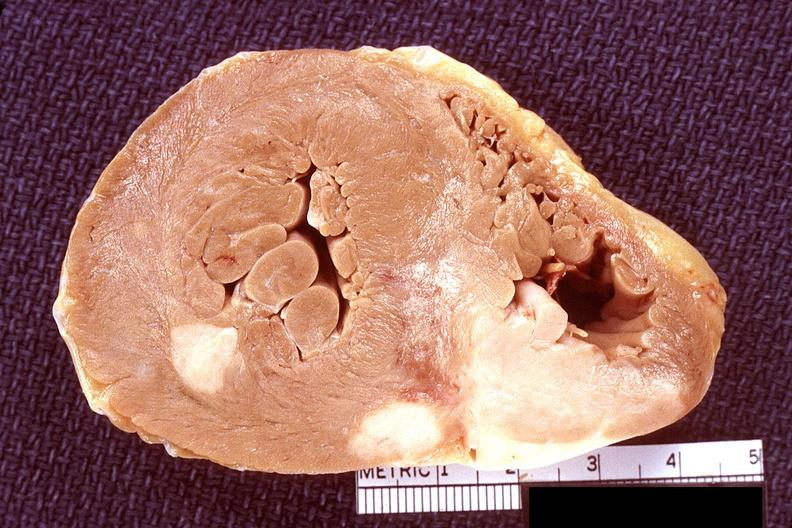s cardiovascular present?
Answer the question using a single word or phrase. Yes 